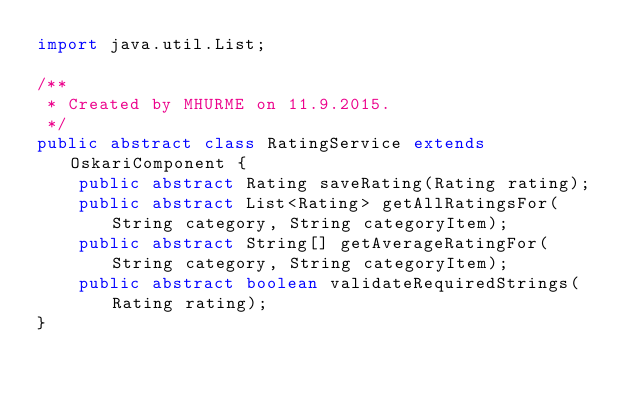Convert code to text. <code><loc_0><loc_0><loc_500><loc_500><_Java_>import java.util.List;

/**
 * Created by MHURME on 11.9.2015.
 */
public abstract class RatingService extends OskariComponent {
    public abstract Rating saveRating(Rating rating);
    public abstract List<Rating> getAllRatingsFor(String category, String categoryItem);
    public abstract String[] getAverageRatingFor(String category, String categoryItem);
    public abstract boolean validateRequiredStrings(Rating rating);
}
</code> 